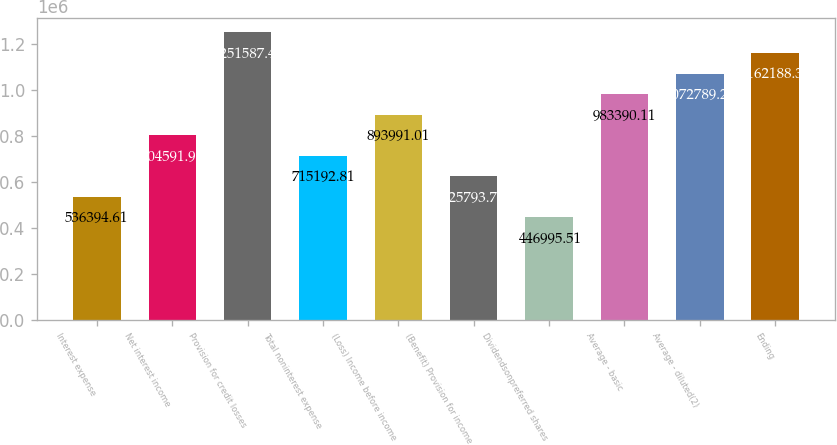Convert chart. <chart><loc_0><loc_0><loc_500><loc_500><bar_chart><fcel>Interest expense<fcel>Net interest income<fcel>Provision for credit losses<fcel>Total noninterest expense<fcel>(Loss) Income before income<fcel>(Benefit) Provision for income<fcel>Dividendsonpreferred shares<fcel>Average - basic<fcel>Average - diluted(2)<fcel>Ending<nl><fcel>536395<fcel>804592<fcel>1.25159e+06<fcel>715193<fcel>893991<fcel>625794<fcel>446996<fcel>983390<fcel>1.07279e+06<fcel>1.16219e+06<nl></chart> 